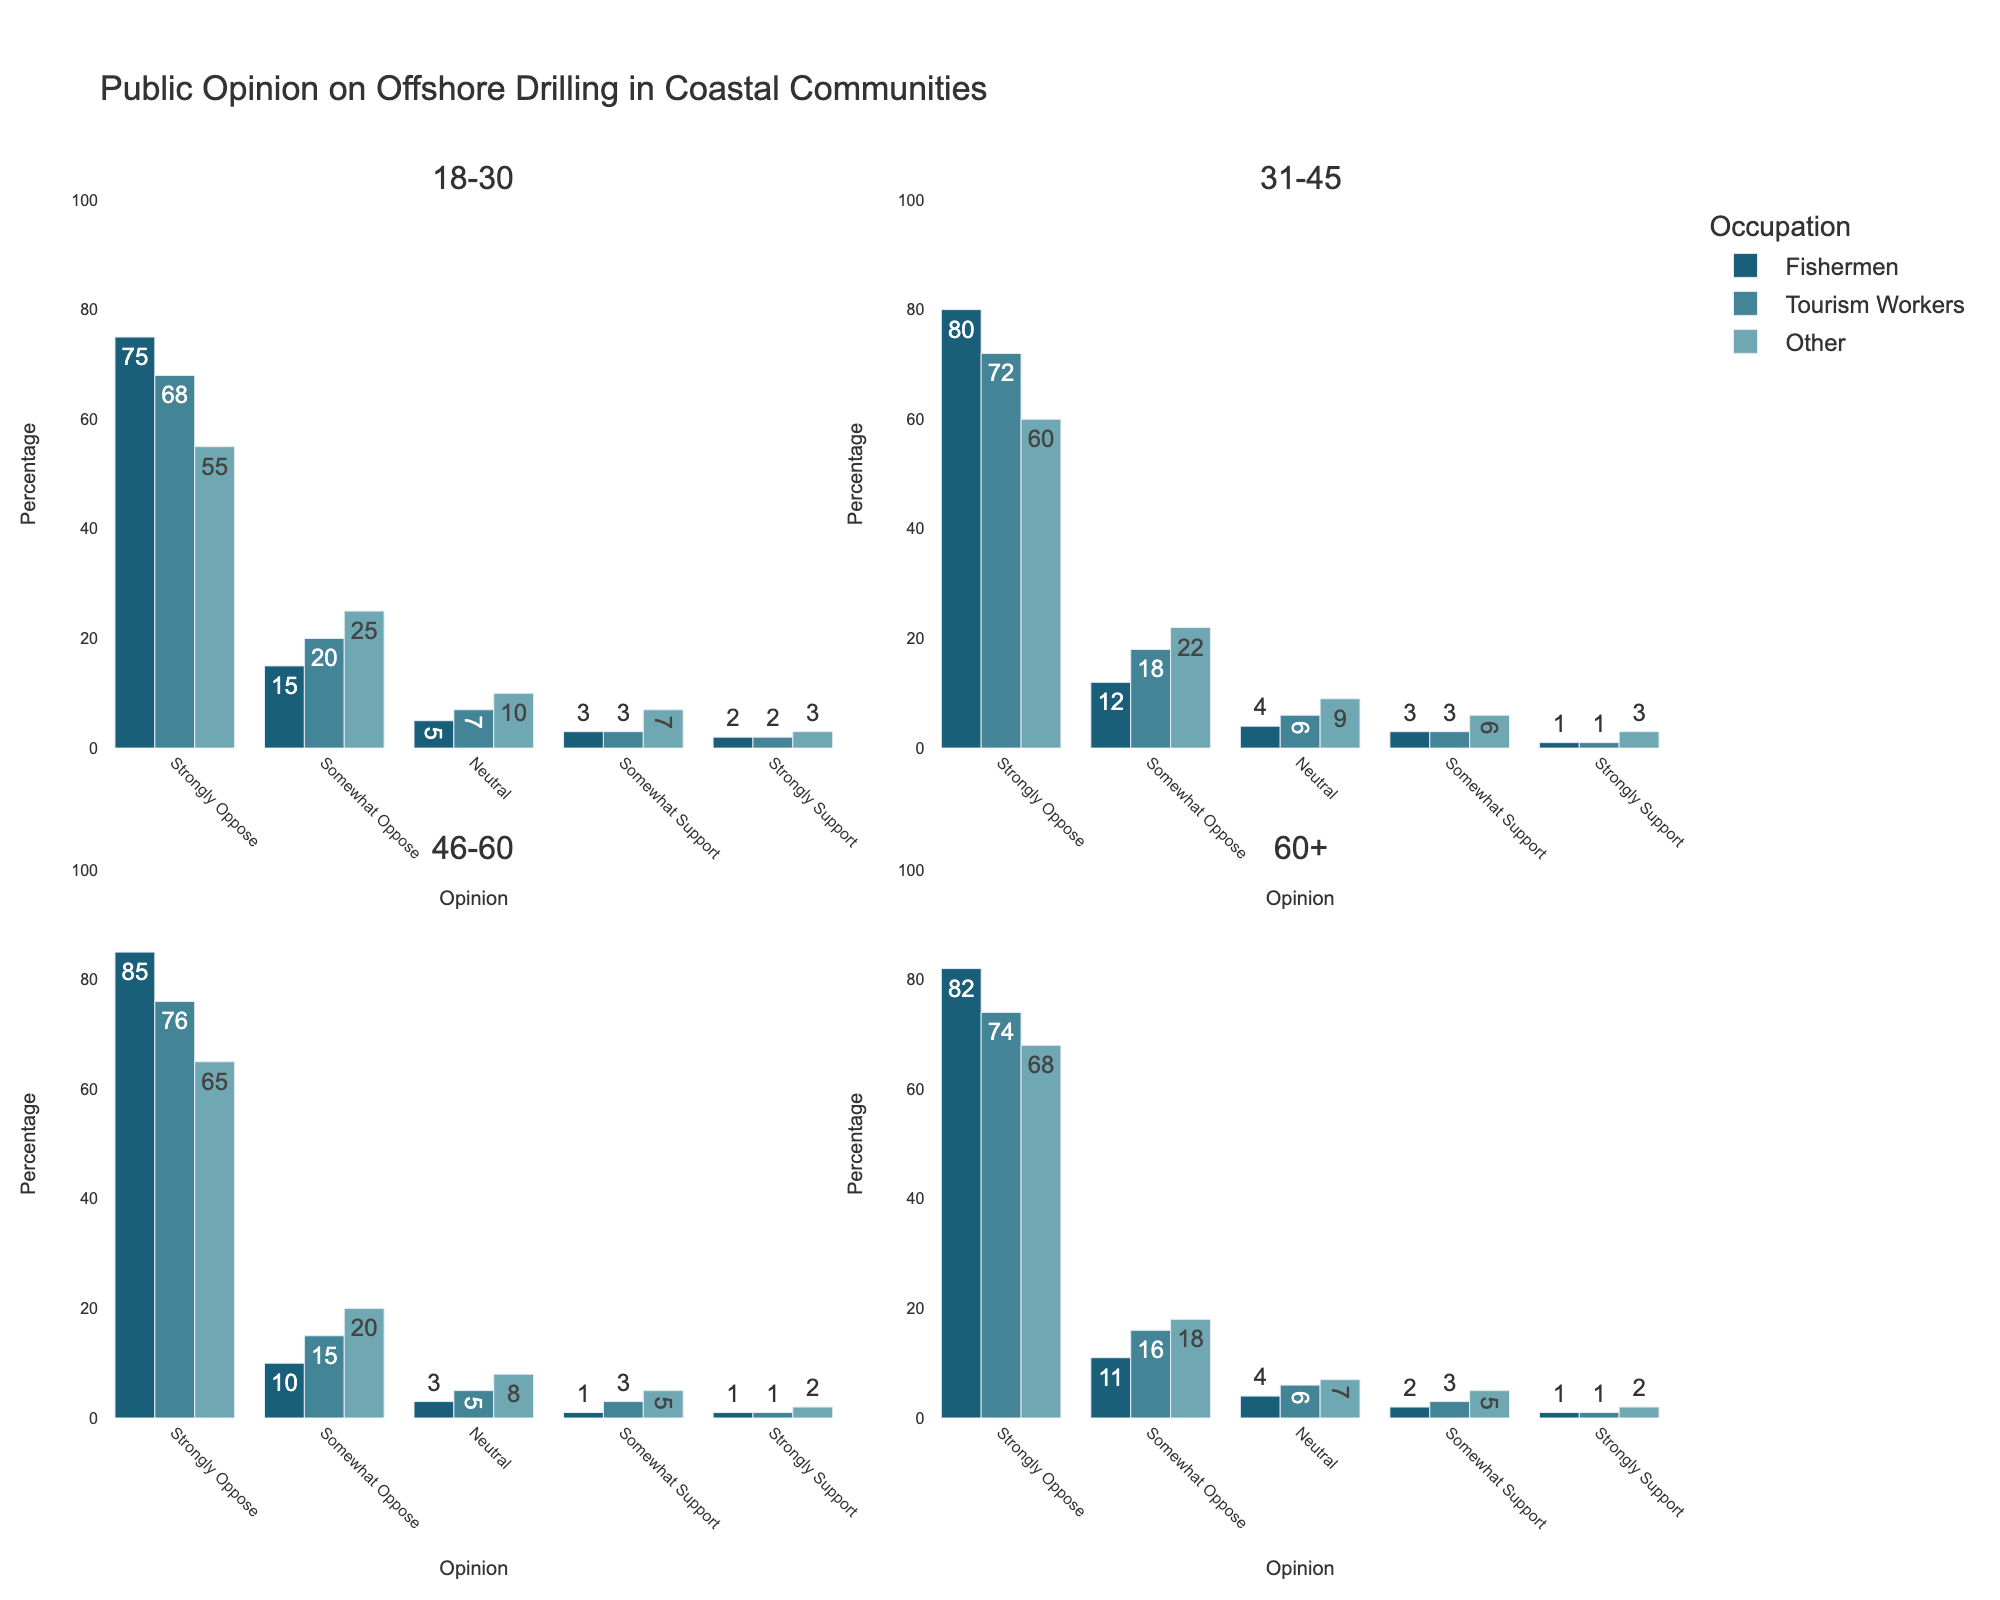What is the most common stance among fishermen aged 18-30? Fishermen aged 18-30 have percentages shown for different opinions, with the "Strongly Oppose" bar being the tallest at 75%. This indicates "Strongly Oppose" is the most common stance.
Answer: Strongly Oppose How does the level of "Strongly Support" for tourism workers aged 31-45 compare to those aged 46-60? Tourism workers aged 31-45 have a "Strongly Support" percentage of 1%, while those aged 46-60 also have a "Strongly Support" percentage of 1%. So, the levels are equal.
Answer: Equal Among people aged 60 and older, which occupation group has the highest percentage of "Somewhat Oppose"? For individuals aged 60+, the "Somewhat Oppose" bar for "Tourism Workers" is taller than those for "Fishermen" and "Other". Thus, "Tourism Workers" have the highest percentage at 16%.
Answer: Tourism Workers What is the combined percentage of "Neutral" opinions for fishermen across all age groups? For fishermen: 18-30 (5%) + 31-45 (4%) + 46-60 (3%) + 60+ (4%). Sum = 5 + 4 + 3 + 4 = 16%.
Answer: 16% Compare the "Strongly Oppose" percentages between fishermen and other occupations aged 31-45. Who has the highest and who has the lowest? Fishermen aged 31-45 have a "Strongly Oppose" percentage of 80%, tourism workers have 72%, and other occupations have 60%. Fishermen have the highest, and other occupations have the lowest.
Answer: Fishermen highest, Other lowest What percentage of 18-30 age group "Tourism Workers" either somewhat or strongly support offshore drilling? Tourism workers aged 18-30 have "Somewhat Support" at 3% and "Strongly Support" at 2%. Sum = 3 + 2 = 5%.
Answer: 5% Which age group of fishermen shows the highest opposition (both Strongly and Somewhat Oppose) to offshore drilling? For fishermen: 18-30 (75%+15%), 31-45 (80%+12%), 46-60 (85%+10%), 60+ (82%+11%). Combining these, 46-60 has the highest at 95%.
Answer: 46-60 Could you compare the "Neutral" opinions held by the 60+ age group between tourism workers and other occupations? Which is higher? For the 60+ age group, tourism workers have 6% as "Neutral", and other occupations have 7%. The other occupations have slightly higher "Neutral" opinions.
Answer: Other occupations Among the 31-45 age group, which occupation has the lowest "Somewhat Support" percentage? In the 31-45 age group, all occupations ("Fishermen," "Tourism Workers," and "Other") have a "Somewhat Support" percentage of 3%. So, they are all equal with the lowest percentage.
Answer: Equal 